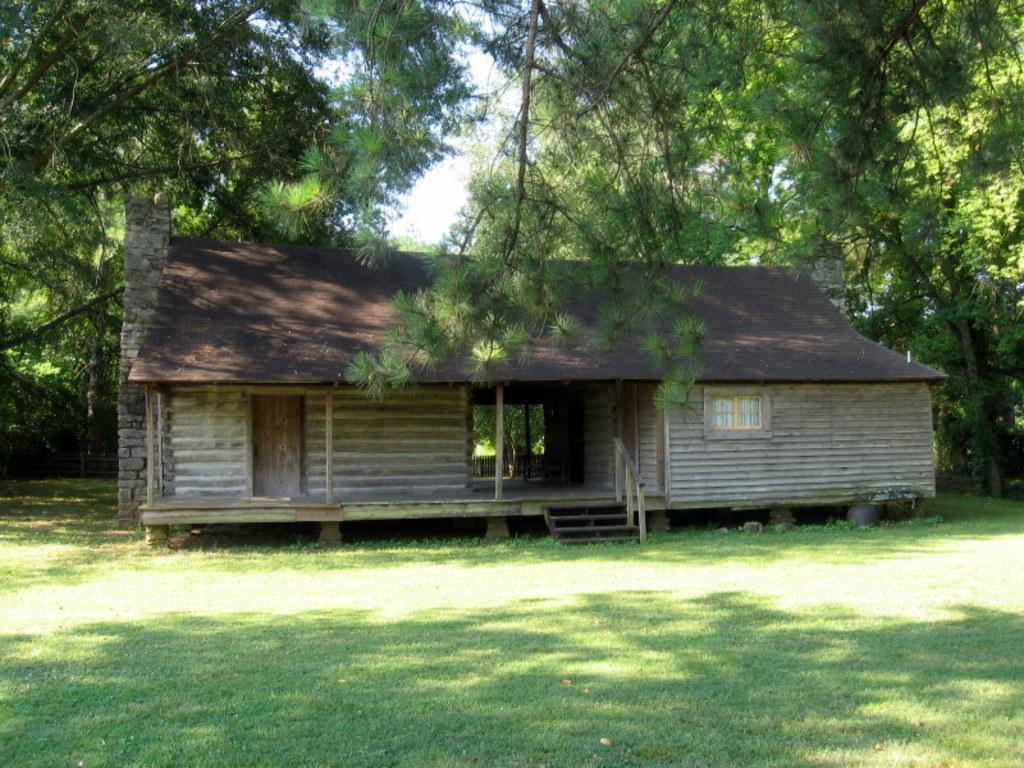Describe this image in one or two sentences. In this picture I can observe a house in the middle of the picture. There is some grass on the ground. In the background there are trees and sky. 